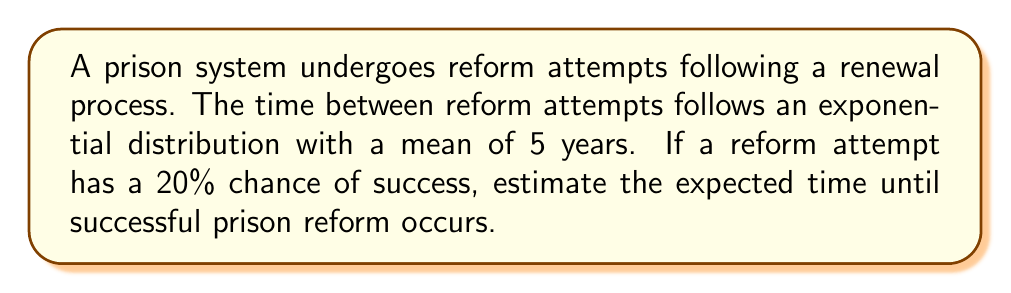Can you answer this question? Let's approach this step-by-step using renewal process theory:

1) First, we need to recognize that this scenario follows a geometric distribution, where we're waiting for the first success in a series of independent trials.

2) The probability of success on any given attempt is $p = 0.2$ (20%).

3) The expected number of trials until success for a geometric distribution is given by:

   $$E[N] = \frac{1}{p} = \frac{1}{0.2} = 5$$

4) Each trial (reform attempt) occurs after an exponentially distributed time with mean 5 years. Let's call this random variable $T$.

5) The expected time until success is the product of the expected number of trials and the expected time between trials:

   $$E[\text{Time until success}] = E[N] \cdot E[T] = 5 \cdot 5 = 25$$

6) Therefore, the expected time until successful prison reform is 25 years.

This renewal process model provides insight into the potentially long-term nature of systemic change, which might resonate with the conflicted feelings of a former prison guard observing reform efforts.
Answer: 25 years 